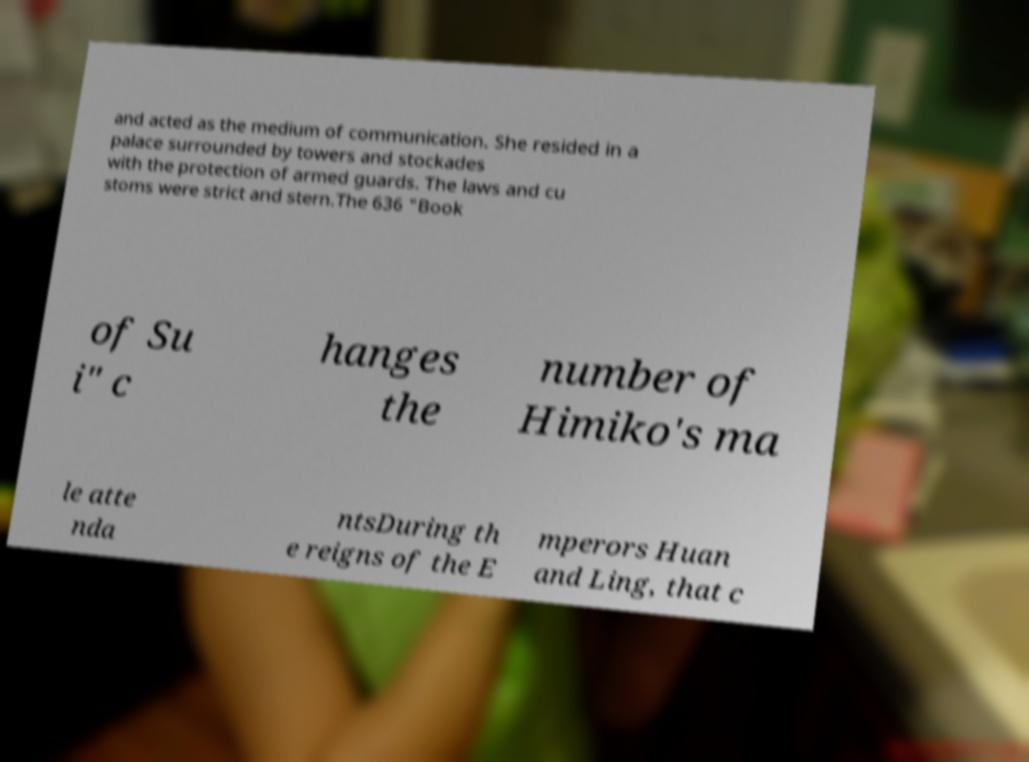Could you extract and type out the text from this image? and acted as the medium of communication. She resided in a palace surrounded by towers and stockades with the protection of armed guards. The laws and cu stoms were strict and stern.The 636 "Book of Su i" c hanges the number of Himiko's ma le atte nda ntsDuring th e reigns of the E mperors Huan and Ling, that c 